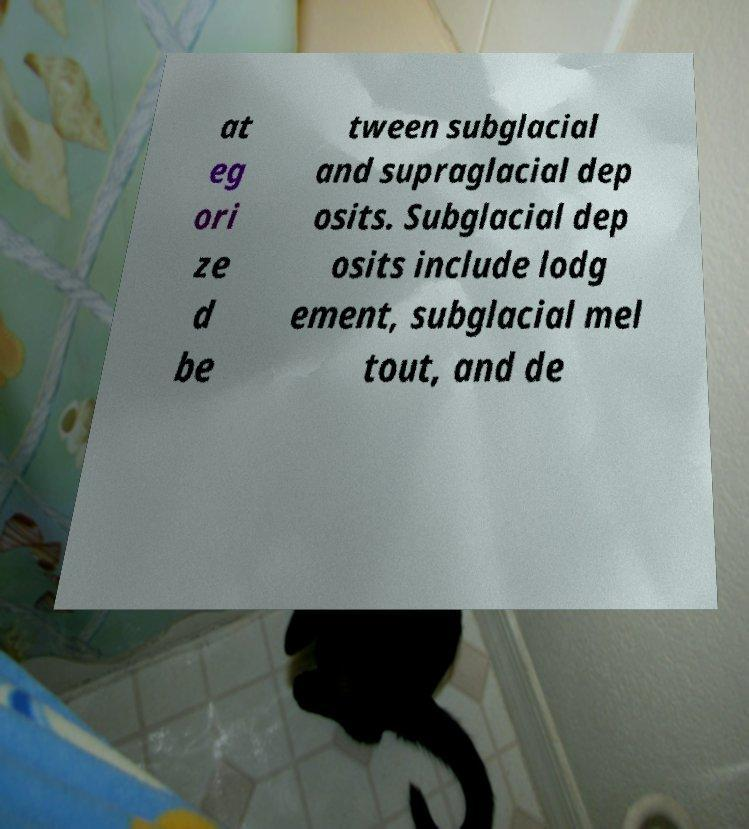Please read and relay the text visible in this image. What does it say? at eg ori ze d be tween subglacial and supraglacial dep osits. Subglacial dep osits include lodg ement, subglacial mel tout, and de 